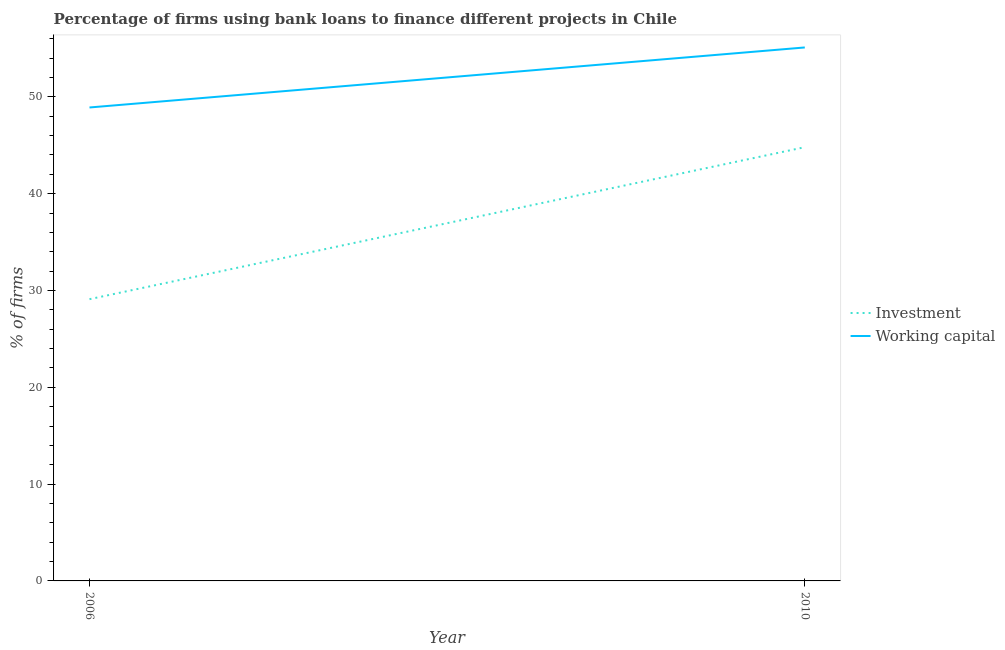How many different coloured lines are there?
Your response must be concise. 2. Is the number of lines equal to the number of legend labels?
Your response must be concise. Yes. What is the percentage of firms using banks to finance investment in 2010?
Provide a short and direct response. 44.8. Across all years, what is the maximum percentage of firms using banks to finance working capital?
Your answer should be very brief. 55.1. Across all years, what is the minimum percentage of firms using banks to finance working capital?
Your answer should be very brief. 48.9. What is the total percentage of firms using banks to finance investment in the graph?
Keep it short and to the point. 73.9. What is the difference between the percentage of firms using banks to finance working capital in 2006 and that in 2010?
Give a very brief answer. -6.2. What is the difference between the percentage of firms using banks to finance investment in 2006 and the percentage of firms using banks to finance working capital in 2010?
Your answer should be compact. -26. What is the average percentage of firms using banks to finance working capital per year?
Make the answer very short. 52. In the year 2010, what is the difference between the percentage of firms using banks to finance working capital and percentage of firms using banks to finance investment?
Your response must be concise. 10.3. What is the ratio of the percentage of firms using banks to finance working capital in 2006 to that in 2010?
Give a very brief answer. 0.89. In how many years, is the percentage of firms using banks to finance working capital greater than the average percentage of firms using banks to finance working capital taken over all years?
Offer a terse response. 1. Does the percentage of firms using banks to finance investment monotonically increase over the years?
Keep it short and to the point. Yes. Is the percentage of firms using banks to finance investment strictly less than the percentage of firms using banks to finance working capital over the years?
Give a very brief answer. Yes. Does the graph contain any zero values?
Provide a short and direct response. No. Where does the legend appear in the graph?
Provide a short and direct response. Center right. How many legend labels are there?
Offer a terse response. 2. What is the title of the graph?
Keep it short and to the point. Percentage of firms using bank loans to finance different projects in Chile. Does "Exports of goods" appear as one of the legend labels in the graph?
Your response must be concise. No. What is the label or title of the Y-axis?
Offer a terse response. % of firms. What is the % of firms of Investment in 2006?
Your answer should be very brief. 29.1. What is the % of firms in Working capital in 2006?
Provide a succinct answer. 48.9. What is the % of firms of Investment in 2010?
Offer a very short reply. 44.8. What is the % of firms of Working capital in 2010?
Provide a succinct answer. 55.1. Across all years, what is the maximum % of firms of Investment?
Ensure brevity in your answer.  44.8. Across all years, what is the maximum % of firms in Working capital?
Keep it short and to the point. 55.1. Across all years, what is the minimum % of firms of Investment?
Keep it short and to the point. 29.1. Across all years, what is the minimum % of firms in Working capital?
Offer a very short reply. 48.9. What is the total % of firms of Investment in the graph?
Your response must be concise. 73.9. What is the total % of firms in Working capital in the graph?
Keep it short and to the point. 104. What is the difference between the % of firms in Investment in 2006 and that in 2010?
Provide a succinct answer. -15.7. What is the average % of firms in Investment per year?
Keep it short and to the point. 36.95. What is the average % of firms in Working capital per year?
Provide a succinct answer. 52. In the year 2006, what is the difference between the % of firms of Investment and % of firms of Working capital?
Your answer should be very brief. -19.8. What is the ratio of the % of firms in Investment in 2006 to that in 2010?
Your answer should be compact. 0.65. What is the ratio of the % of firms of Working capital in 2006 to that in 2010?
Provide a short and direct response. 0.89. What is the difference between the highest and the second highest % of firms of Investment?
Your answer should be compact. 15.7. What is the difference between the highest and the lowest % of firms of Working capital?
Keep it short and to the point. 6.2. 